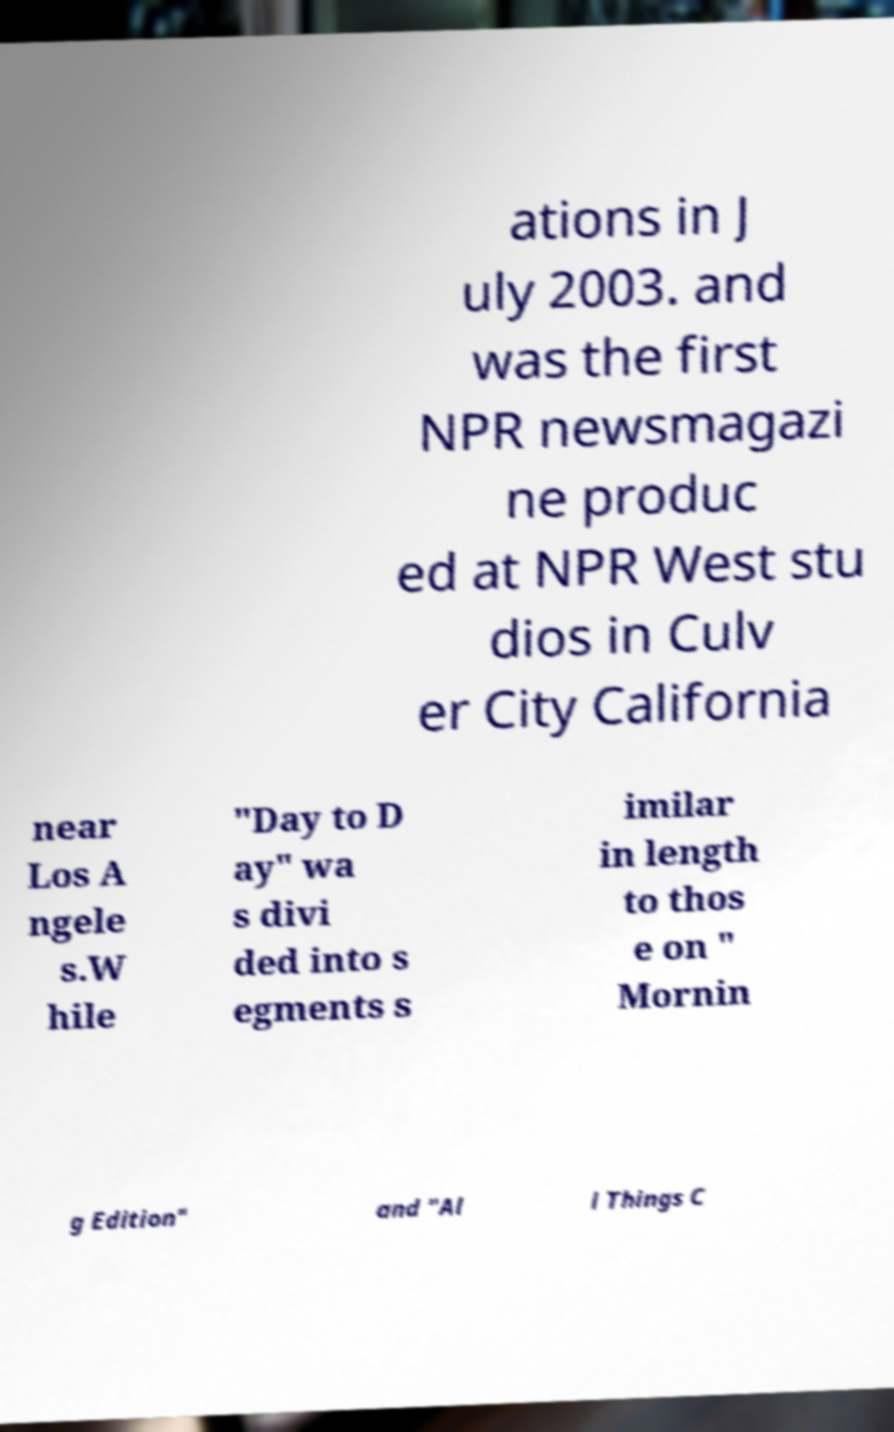Could you assist in decoding the text presented in this image and type it out clearly? ations in J uly 2003. and was the first NPR newsmagazi ne produc ed at NPR West stu dios in Culv er City California near Los A ngele s.W hile "Day to D ay" wa s divi ded into s egments s imilar in length to thos e on " Mornin g Edition" and "Al l Things C 